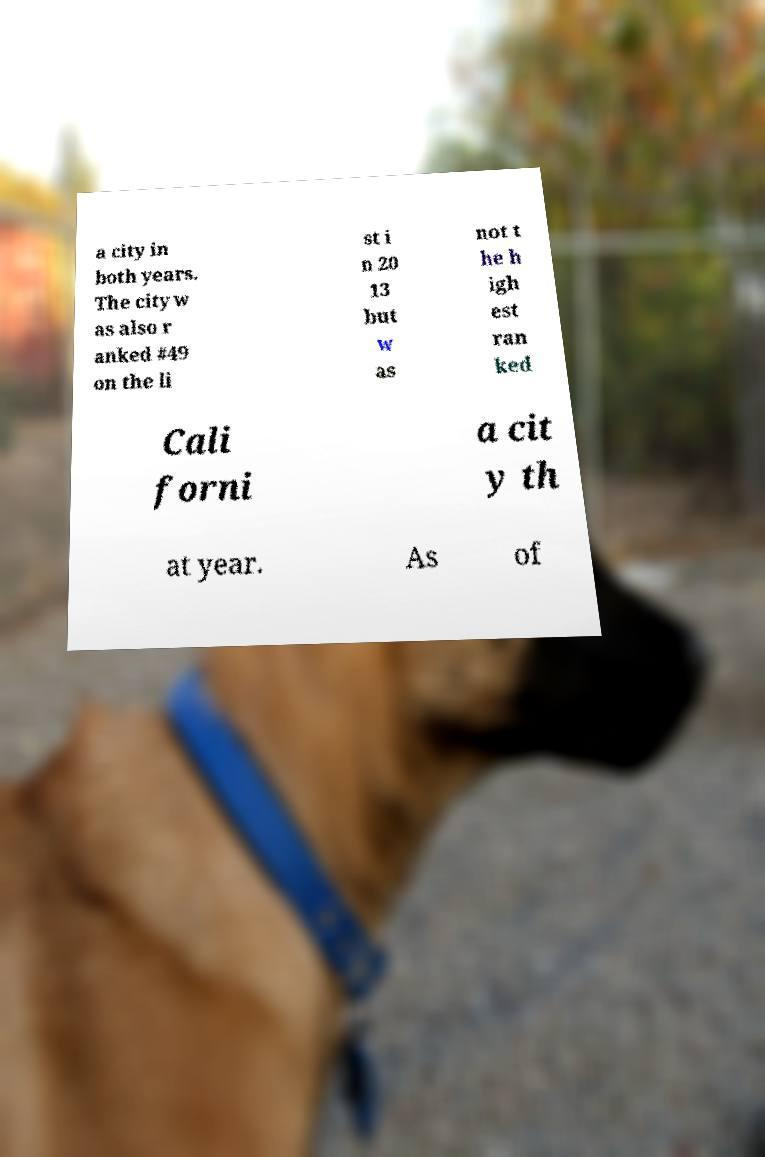What messages or text are displayed in this image? I need them in a readable, typed format. a city in both years. The city w as also r anked #49 on the li st i n 20 13 but w as not t he h igh est ran ked Cali forni a cit y th at year. As of 